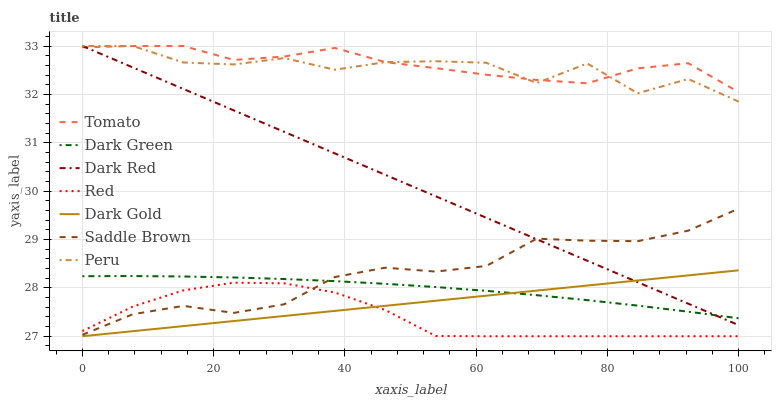Does Red have the minimum area under the curve?
Answer yes or no. Yes. Does Tomato have the maximum area under the curve?
Answer yes or no. Yes. Does Dark Gold have the minimum area under the curve?
Answer yes or no. No. Does Dark Gold have the maximum area under the curve?
Answer yes or no. No. Is Dark Gold the smoothest?
Answer yes or no. Yes. Is Peru the roughest?
Answer yes or no. Yes. Is Dark Red the smoothest?
Answer yes or no. No. Is Dark Red the roughest?
Answer yes or no. No. Does Dark Gold have the lowest value?
Answer yes or no. Yes. Does Dark Red have the lowest value?
Answer yes or no. No. Does Peru have the highest value?
Answer yes or no. Yes. Does Dark Gold have the highest value?
Answer yes or no. No. Is Red less than Tomato?
Answer yes or no. Yes. Is Saddle Brown greater than Dark Gold?
Answer yes or no. Yes. Does Dark Green intersect Dark Red?
Answer yes or no. Yes. Is Dark Green less than Dark Red?
Answer yes or no. No. Is Dark Green greater than Dark Red?
Answer yes or no. No. Does Red intersect Tomato?
Answer yes or no. No. 